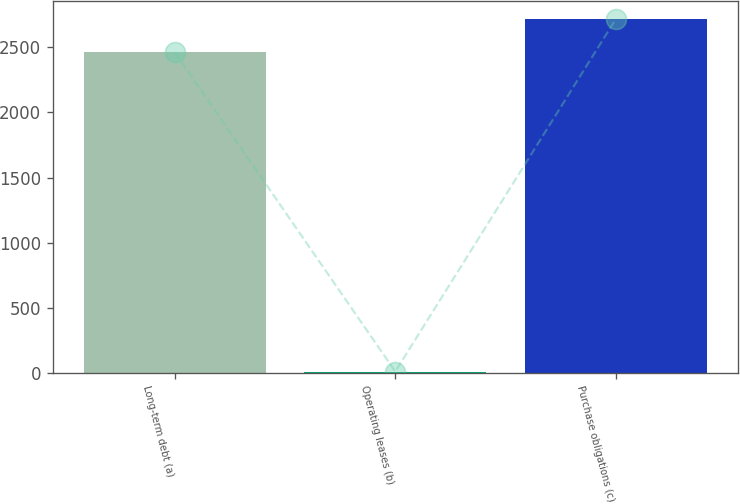<chart> <loc_0><loc_0><loc_500><loc_500><bar_chart><fcel>Long-term debt (a)<fcel>Operating leases (b)<fcel>Purchase obligations (c)<nl><fcel>2461<fcel>13<fcel>2714.6<nl></chart> 